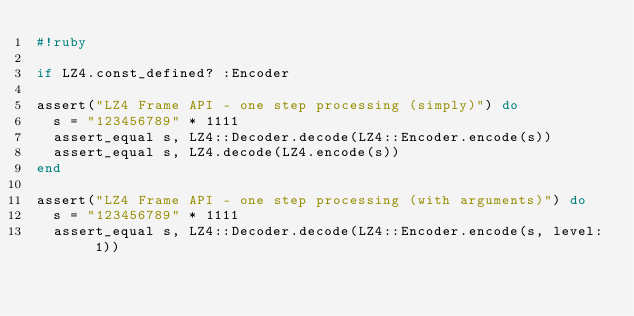Convert code to text. <code><loc_0><loc_0><loc_500><loc_500><_Ruby_>#!ruby

if LZ4.const_defined? :Encoder

assert("LZ4 Frame API - one step processing (simply)") do
  s = "123456789" * 1111
  assert_equal s, LZ4::Decoder.decode(LZ4::Encoder.encode(s))
  assert_equal s, LZ4.decode(LZ4.encode(s))
end

assert("LZ4 Frame API - one step processing (with arguments)") do
  s = "123456789" * 1111
  assert_equal s, LZ4::Decoder.decode(LZ4::Encoder.encode(s, level: 1))</code> 